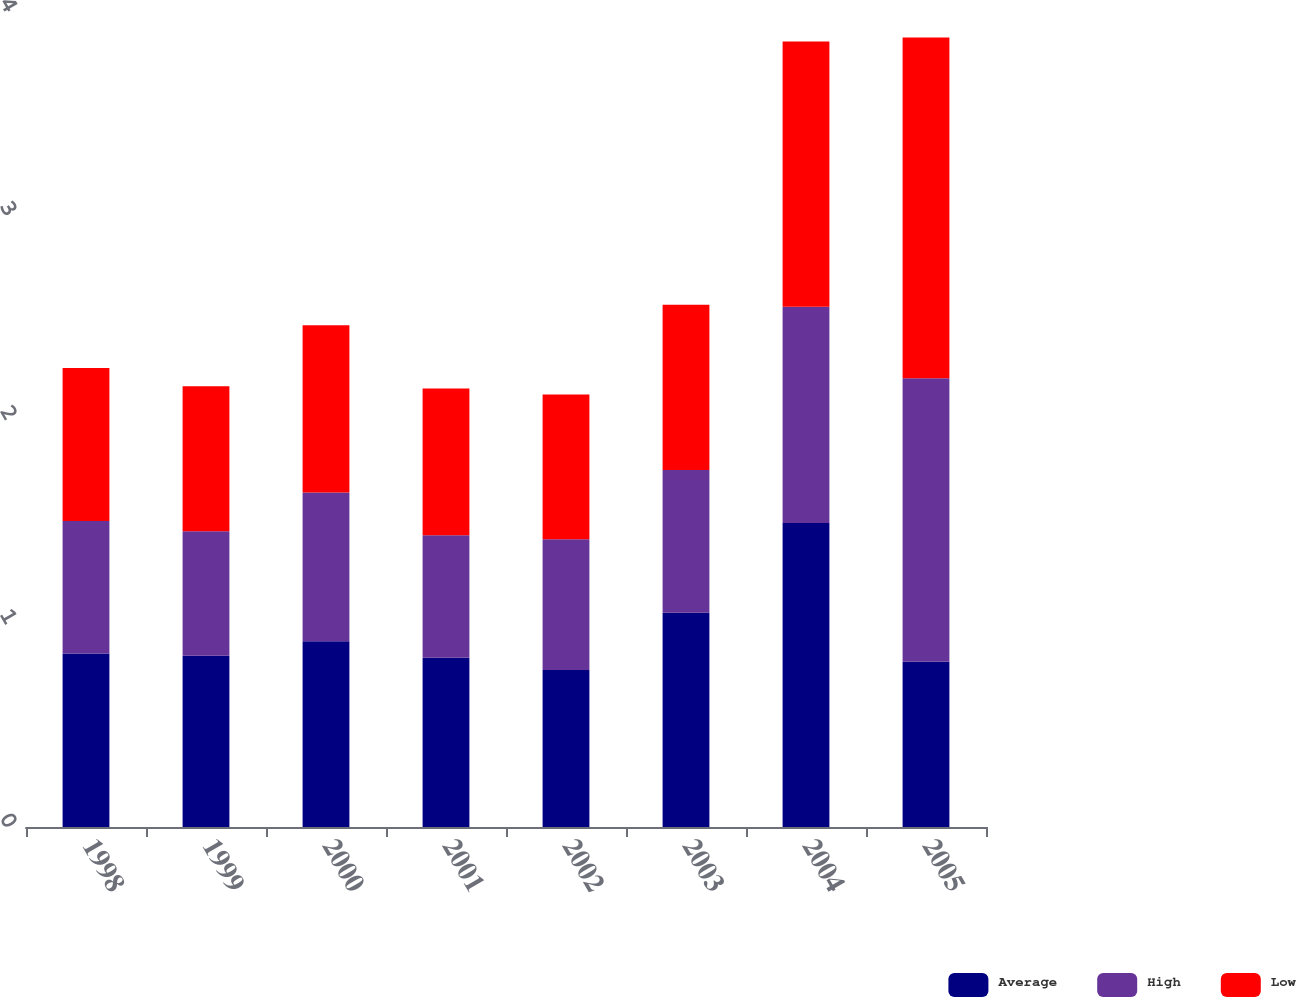<chart> <loc_0><loc_0><loc_500><loc_500><stacked_bar_chart><ecel><fcel>1998<fcel>1999<fcel>2000<fcel>2001<fcel>2002<fcel>2003<fcel>2004<fcel>2005<nl><fcel>Average<fcel>0.85<fcel>0.84<fcel>0.91<fcel>0.83<fcel>0.77<fcel>1.05<fcel>1.49<fcel>0.81<nl><fcel>High<fcel>0.65<fcel>0.61<fcel>0.73<fcel>0.6<fcel>0.64<fcel>0.7<fcel>1.06<fcel>1.39<nl><fcel>Low<fcel>0.75<fcel>0.71<fcel>0.82<fcel>0.72<fcel>0.71<fcel>0.81<fcel>1.3<fcel>1.67<nl></chart> 